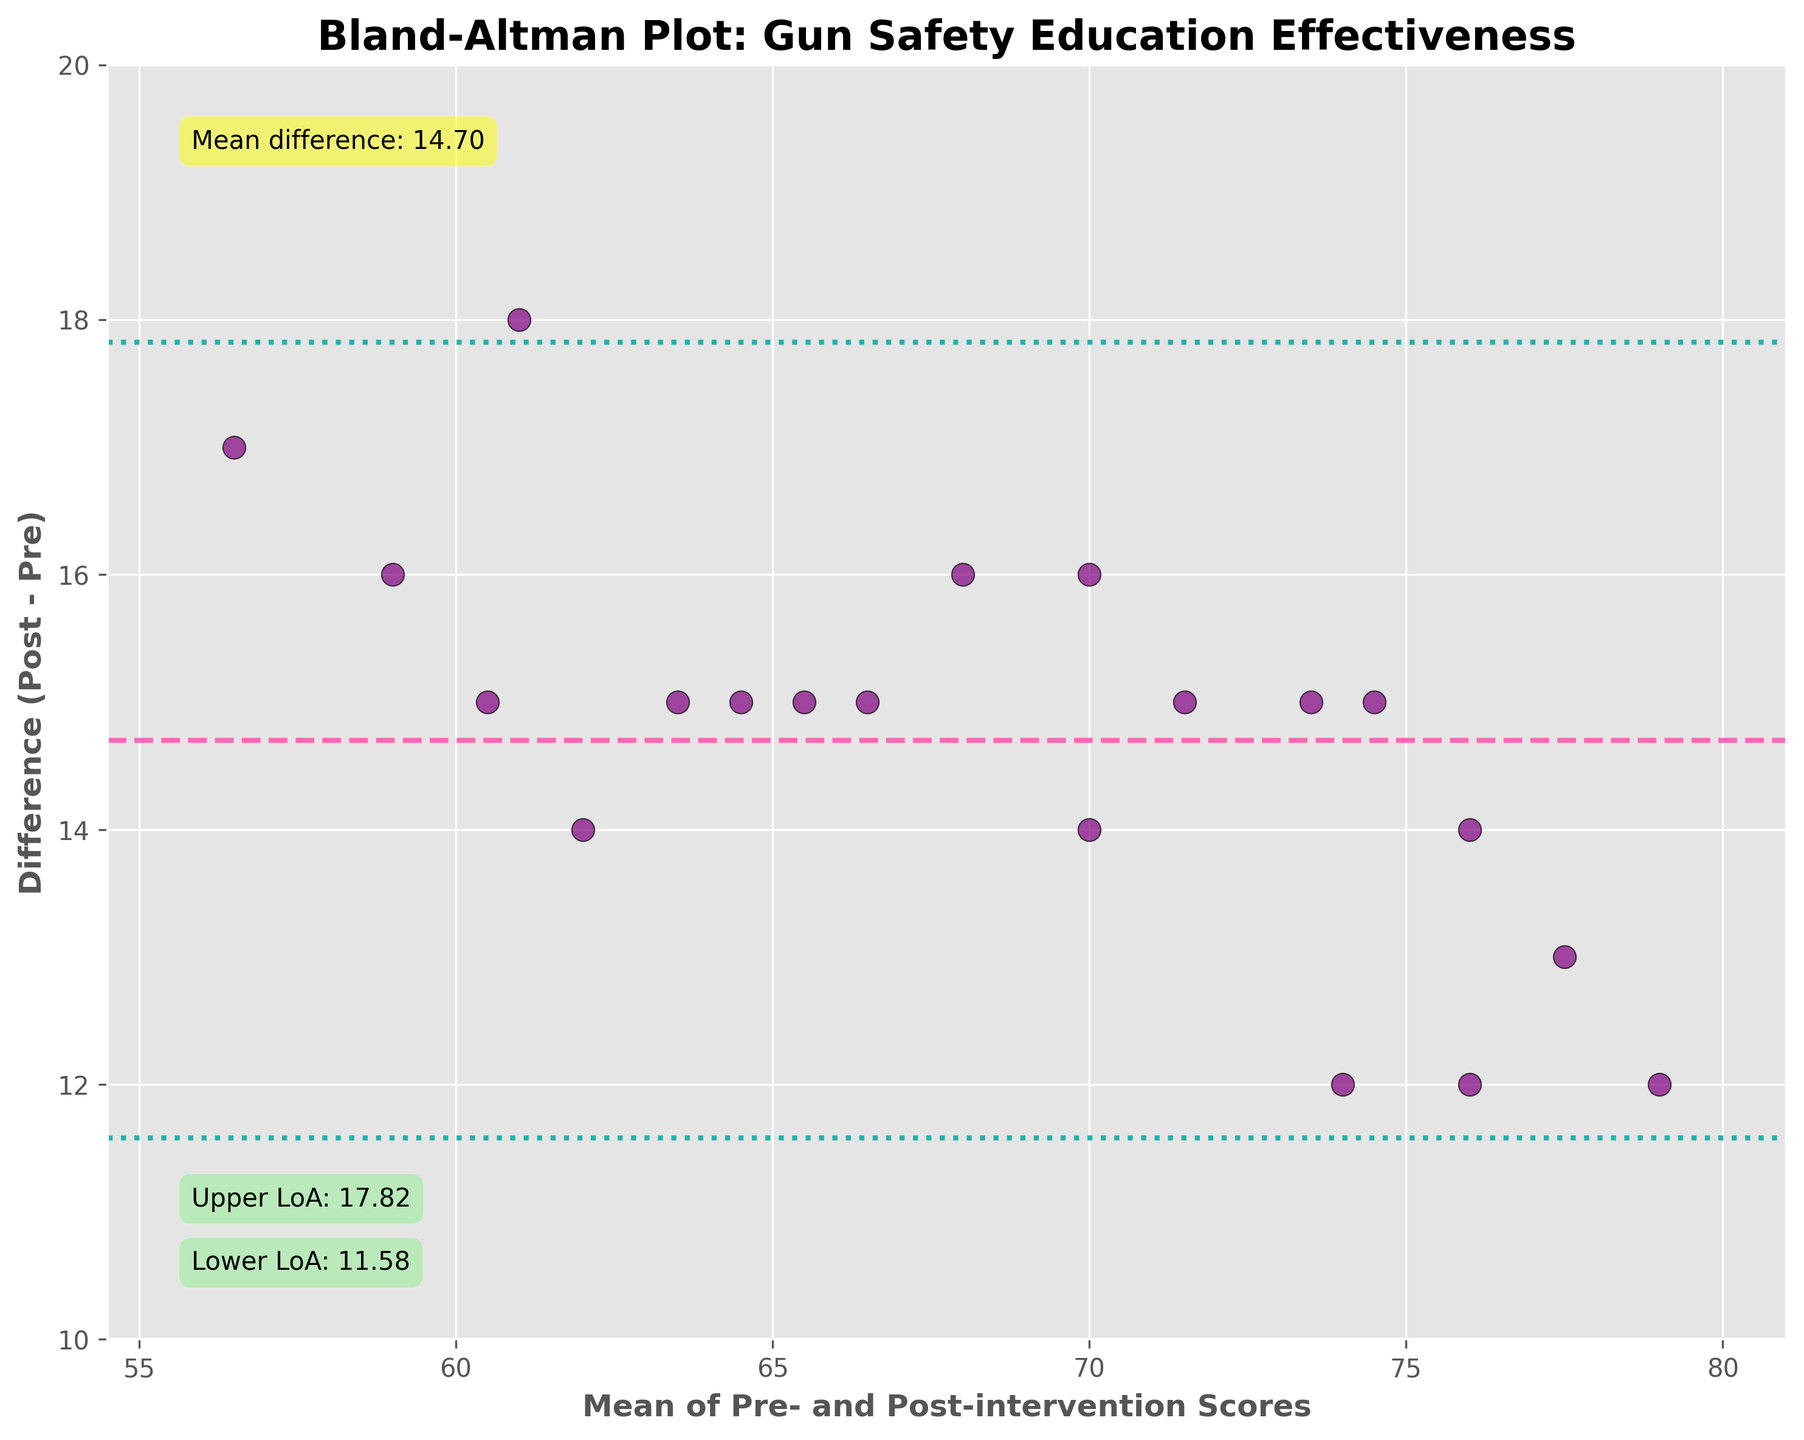What is the title of the plot? The title of the plot is a basic visual element usually located at the top of the figure. In this plot, it is easily readable.
Answer: Bland-Altman Plot: Gun Safety Education Effectiveness What does the x-axis represent? The x-axis is labeled with a descriptive title. In this plot, the label indicates the content it represents.
Answer: Mean of Pre- and Post-intervention Scores How many data points are shown in the figure? By counting the distinct scatter points displayed within the plot, we get the total number of data points.
Answer: 20 What color are the data points? The scatter points are unique in color, making them identifiable in the plot. Looking at the plot reveals this.
Answer: Purple What is the range of the y-axis? The y-axis displays the range of values. By examining the position of the tick marks and their labels, we can determine the range.
Answer: -2 to 20 What is the mean difference between the pre- and post-intervention scores? The mean difference is often annotated or highlighted within these plots for clarity. It’s represented by the pink dashed line and the appropriate annotation on the plot.
Answer: 14.4 What are the limits of agreement in the plot? Limits of agreement are visually marked by horizontal dotted lines and are often annotated. In this plot, they are the bounds within which most differences lie.
Answer: -0.60 and 29.40 What does the pink dashed line represent in the plot? The pink dashed line often corresponds to a critical statistic related to the data differences. It is labeled appropriately for clarity.
Answer: Mean difference Are there any data points outside the limits of agreement? By examining the scatter points relative to the dotted lines marking the limits of agreement, we can count any outliers.
Answer: No What can be inferred if a data point lies far outside the limits of agreement? When a data point lies outside the limits of agreement, it suggests an inconsistency or large discrepancy between the pre- and post-intervention scores for that specific case. Such insights are typical interpretations of Bland-Altman plots.
Answer: It suggests high discrepancy between scores 